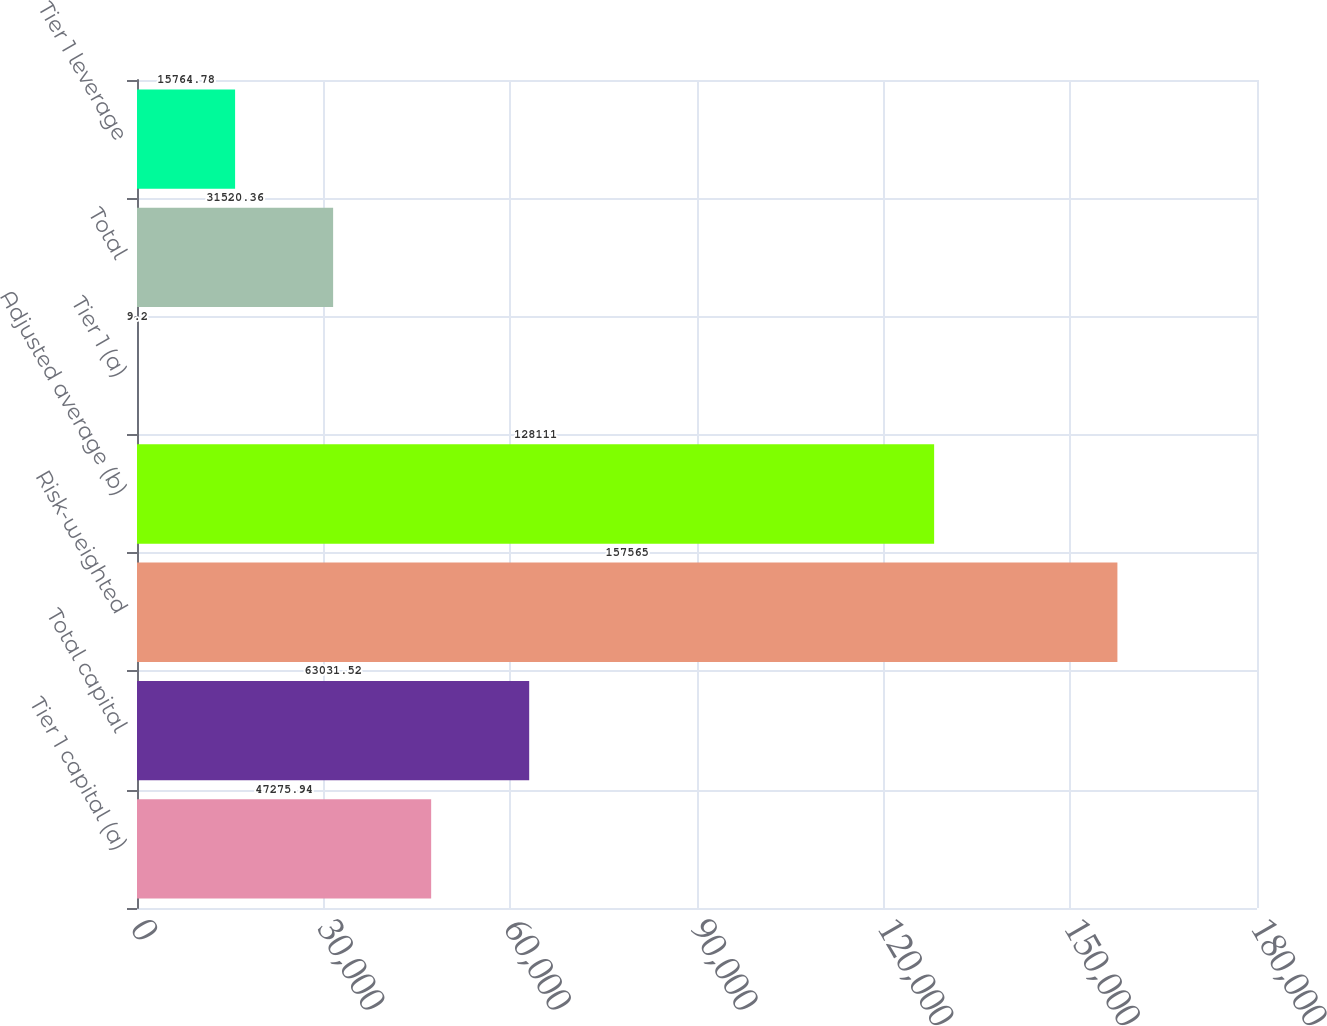<chart> <loc_0><loc_0><loc_500><loc_500><bar_chart><fcel>Tier 1 capital (a)<fcel>Total capital<fcel>Risk-weighted<fcel>Adjusted average (b)<fcel>Tier 1 (a)<fcel>Total<fcel>Tier 1 leverage<nl><fcel>47275.9<fcel>63031.5<fcel>157565<fcel>128111<fcel>9.2<fcel>31520.4<fcel>15764.8<nl></chart> 